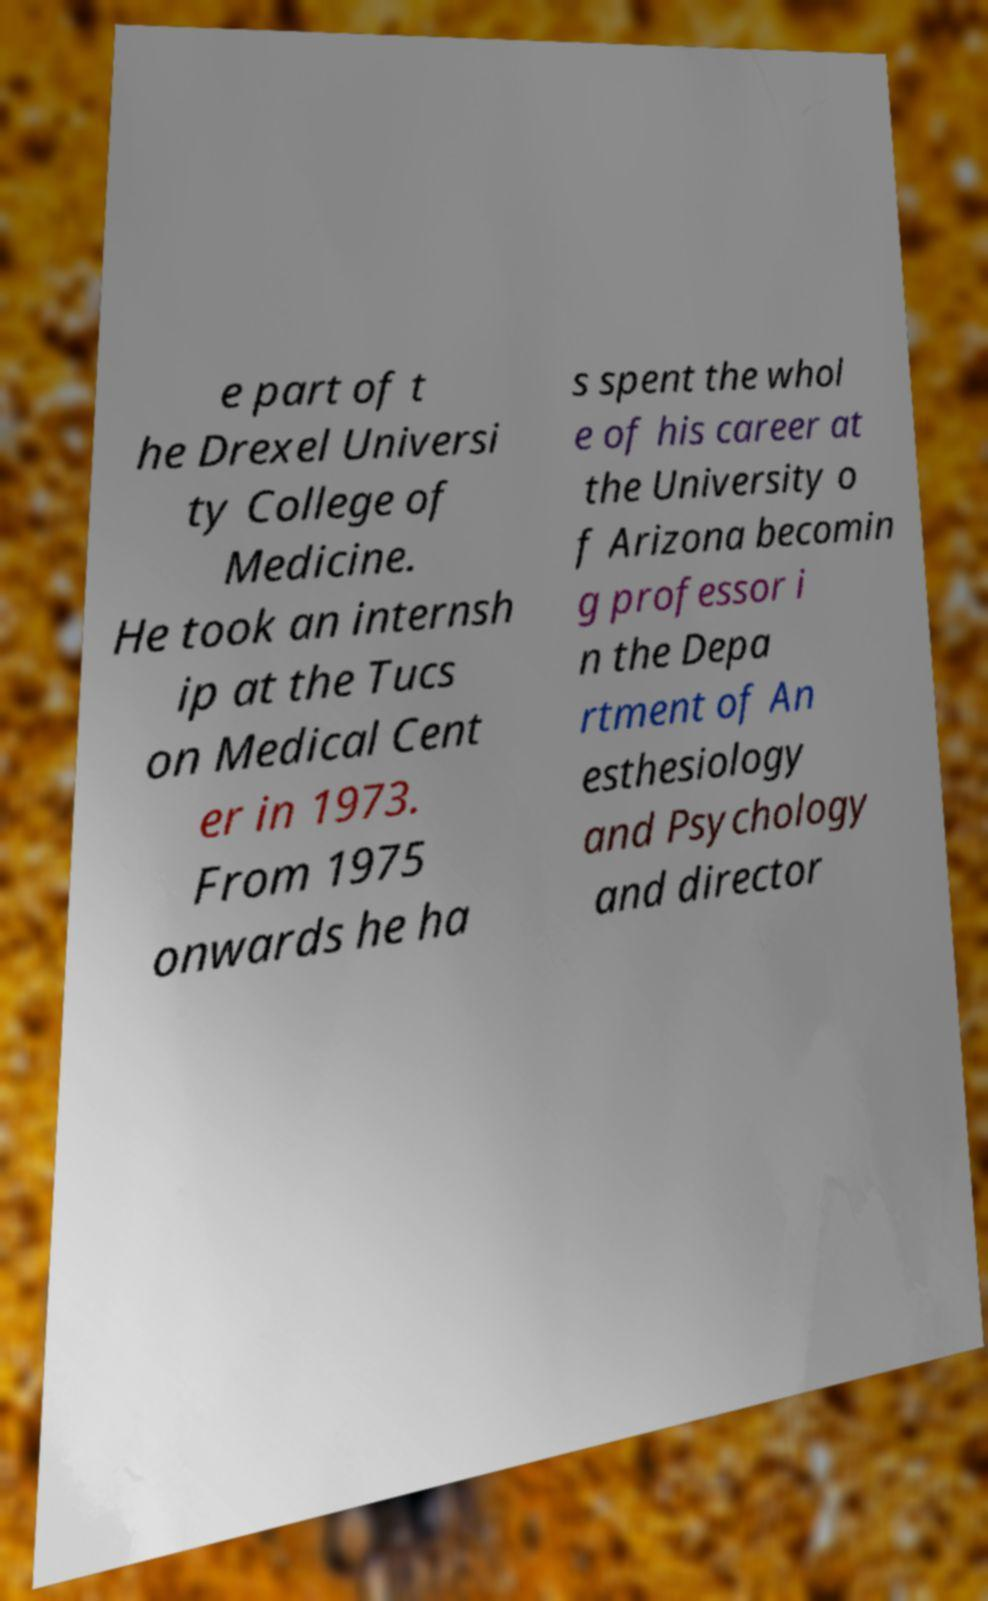Can you read and provide the text displayed in the image?This photo seems to have some interesting text. Can you extract and type it out for me? e part of t he Drexel Universi ty College of Medicine. He took an internsh ip at the Tucs on Medical Cent er in 1973. From 1975 onwards he ha s spent the whol e of his career at the University o f Arizona becomin g professor i n the Depa rtment of An esthesiology and Psychology and director 